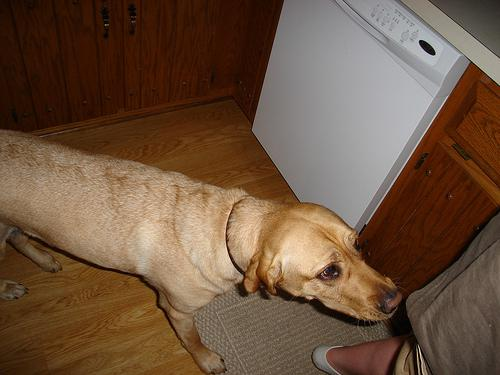Question: what color is the dishwasher?
Choices:
A. Black.
B. It is white.
C. Silver.
D. Red.
Answer with the letter. Answer: B Question: how many dogs are there?
Choices:
A. 2.
B. 3.
C. 1 dog.
D. 4.
Answer with the letter. Answer: C Question: where was the picture taken?
Choices:
A. Dining room.
B. Living room.
C. Bathroom.
D. In a kitchen.
Answer with the letter. Answer: D 